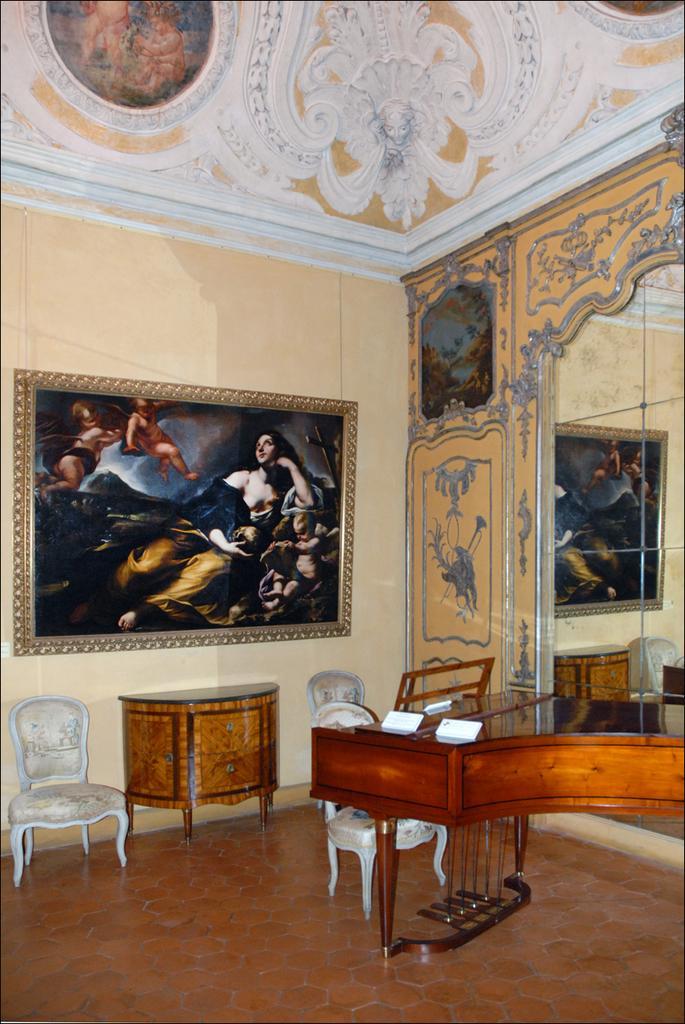In one or two sentences, can you explain what this image depicts? In this image I can see few papers on the table and the table is in brown color. Background I can see few chairs in white color, a frame attached to the wall and the wall is in cream color. 